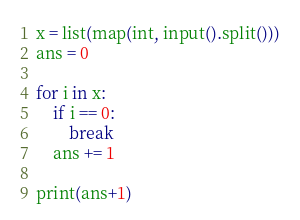<code> <loc_0><loc_0><loc_500><loc_500><_Python_>x = list(map(int, input().split()))
ans = 0

for i in x:
    if i == 0:
        break
    ans += 1

print(ans+1)</code> 